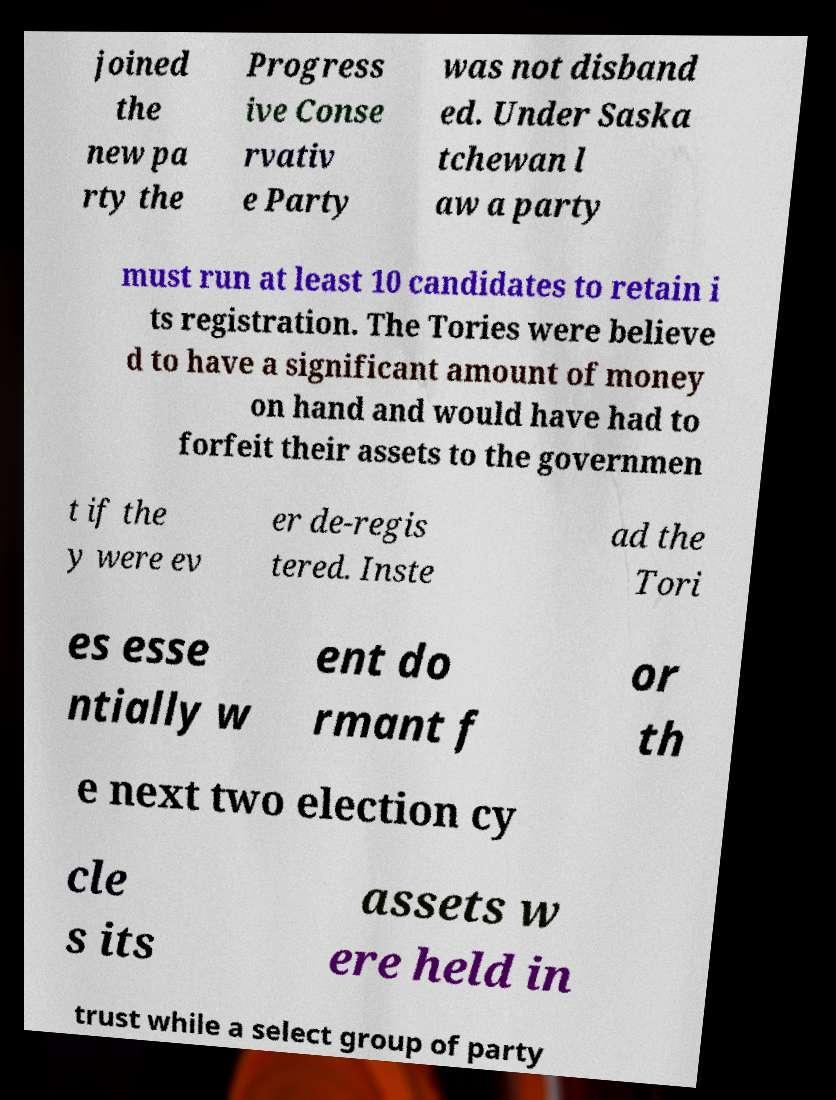I need the written content from this picture converted into text. Can you do that? joined the new pa rty the Progress ive Conse rvativ e Party was not disband ed. Under Saska tchewan l aw a party must run at least 10 candidates to retain i ts registration. The Tories were believe d to have a significant amount of money on hand and would have had to forfeit their assets to the governmen t if the y were ev er de-regis tered. Inste ad the Tori es esse ntially w ent do rmant f or th e next two election cy cle s its assets w ere held in trust while a select group of party 